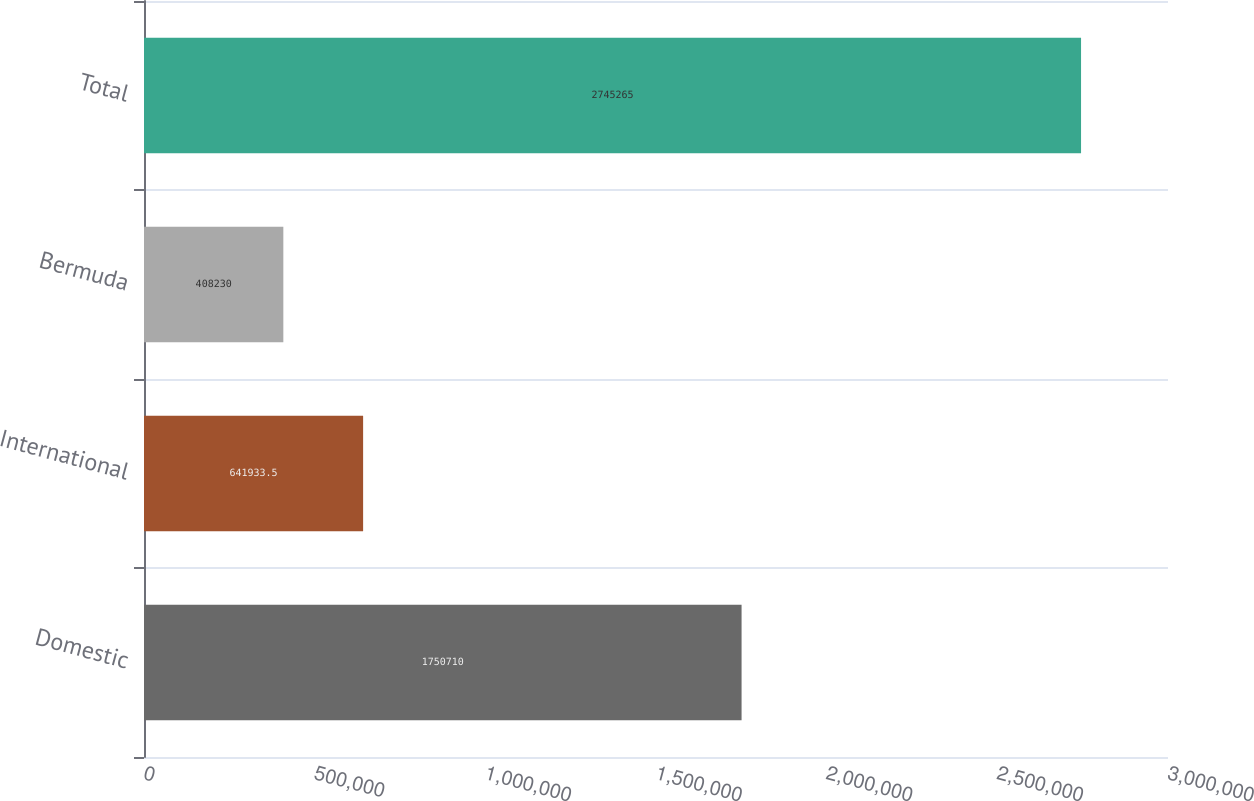<chart> <loc_0><loc_0><loc_500><loc_500><bar_chart><fcel>Domestic<fcel>International<fcel>Bermuda<fcel>Total<nl><fcel>1.75071e+06<fcel>641934<fcel>408230<fcel>2.74526e+06<nl></chart> 